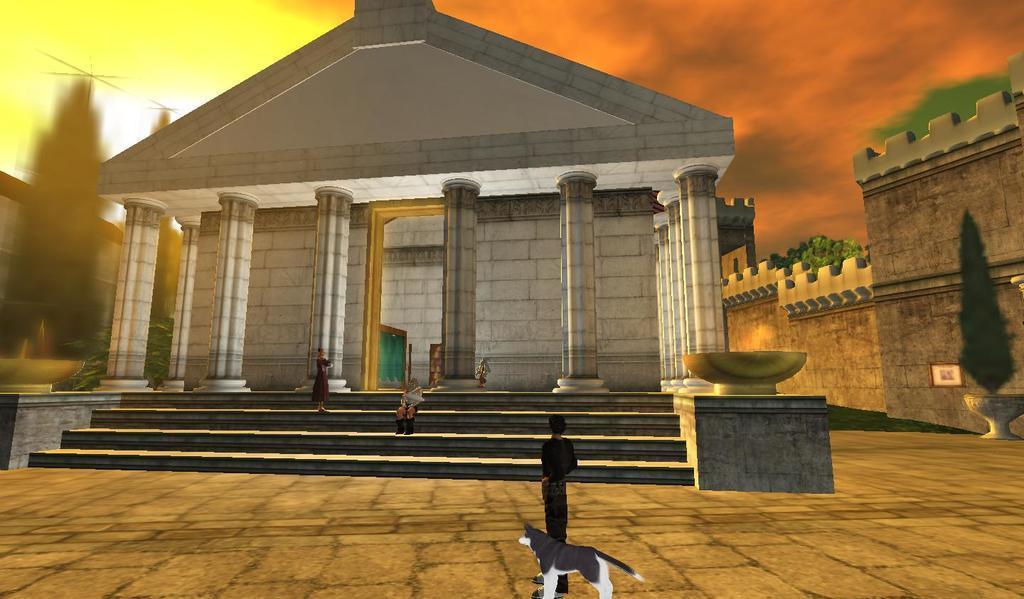Describe this image in one or two sentences. In this picture I can see there is a person standing here and there is a dog standing with the person. In the backdrop there is a building and there are few stairs, there are two people one of them is sitting and the other is standing at the stairs. There are pillars and door in the backdrop. There is a plant into right and there is a wall. The sky is clear. 